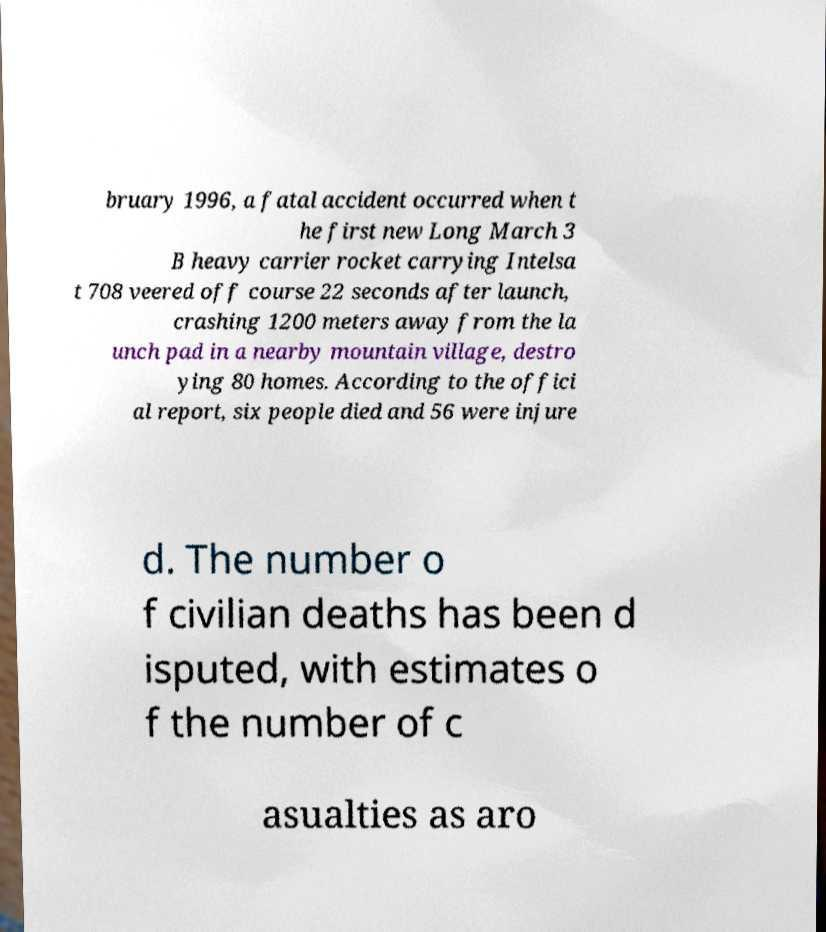I need the written content from this picture converted into text. Can you do that? bruary 1996, a fatal accident occurred when t he first new Long March 3 B heavy carrier rocket carrying Intelsa t 708 veered off course 22 seconds after launch, crashing 1200 meters away from the la unch pad in a nearby mountain village, destro ying 80 homes. According to the offici al report, six people died and 56 were injure d. The number o f civilian deaths has been d isputed, with estimates o f the number of c asualties as aro 